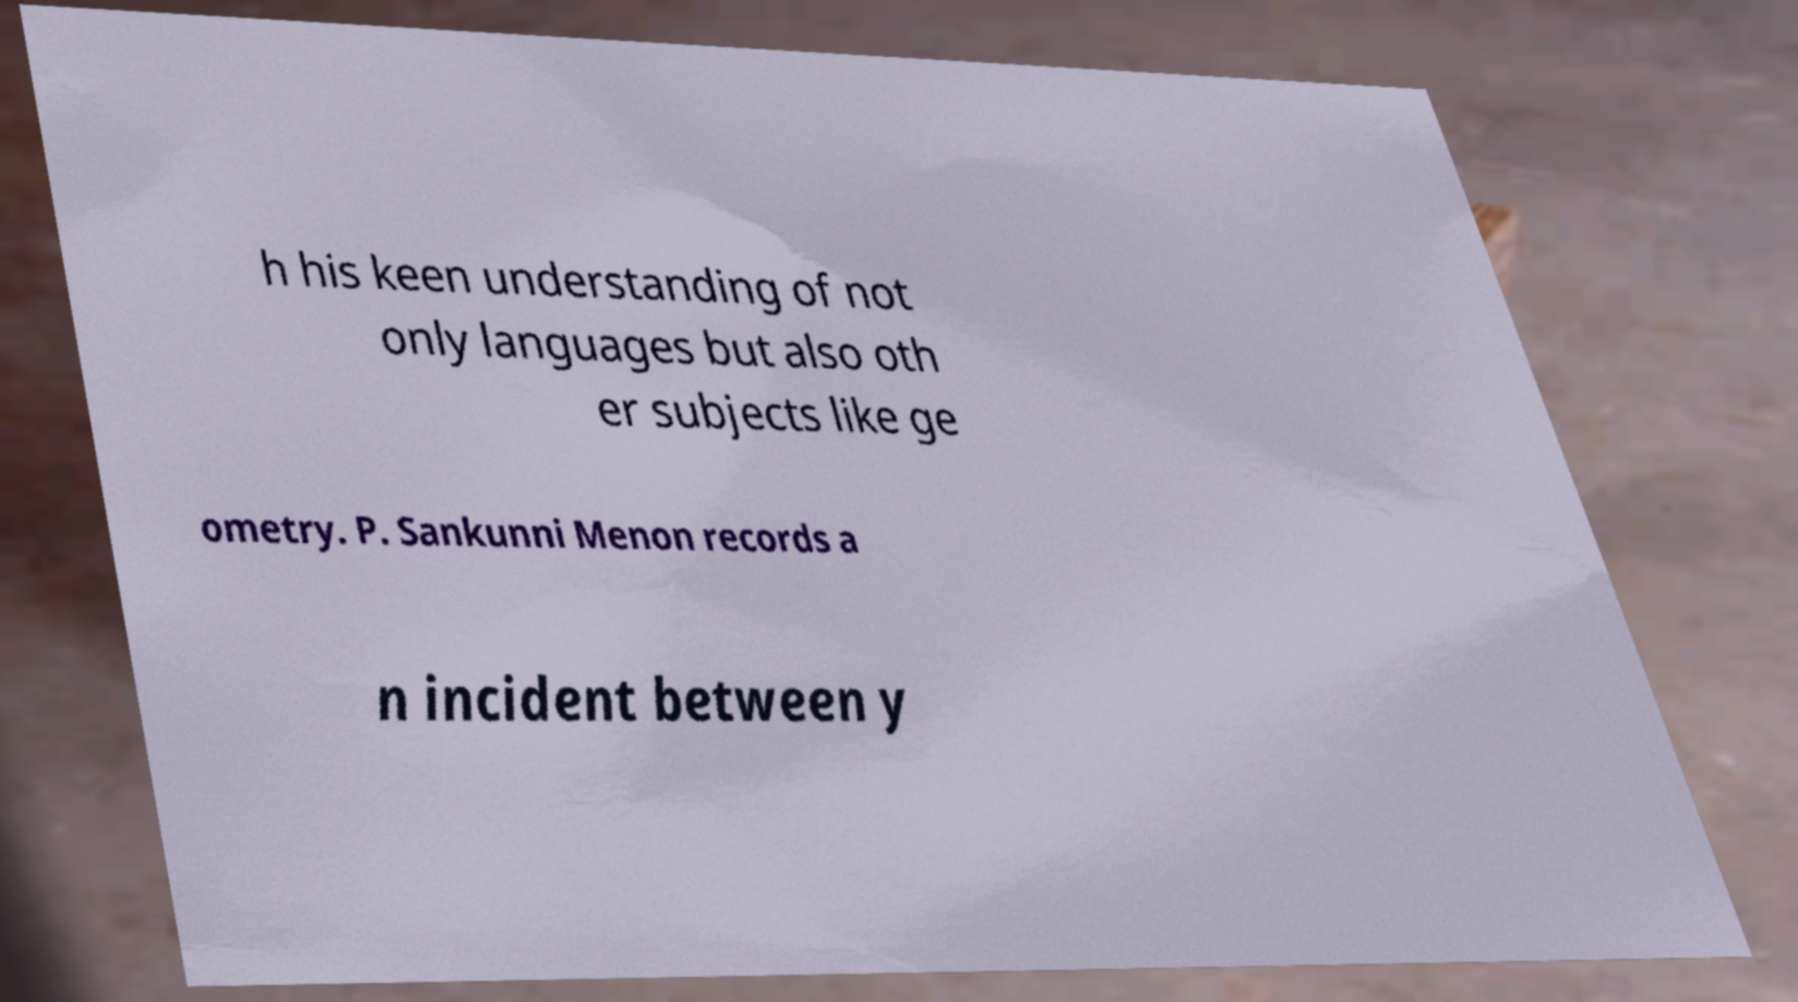Can you accurately transcribe the text from the provided image for me? h his keen understanding of not only languages but also oth er subjects like ge ometry. P. Sankunni Menon records a n incident between y 